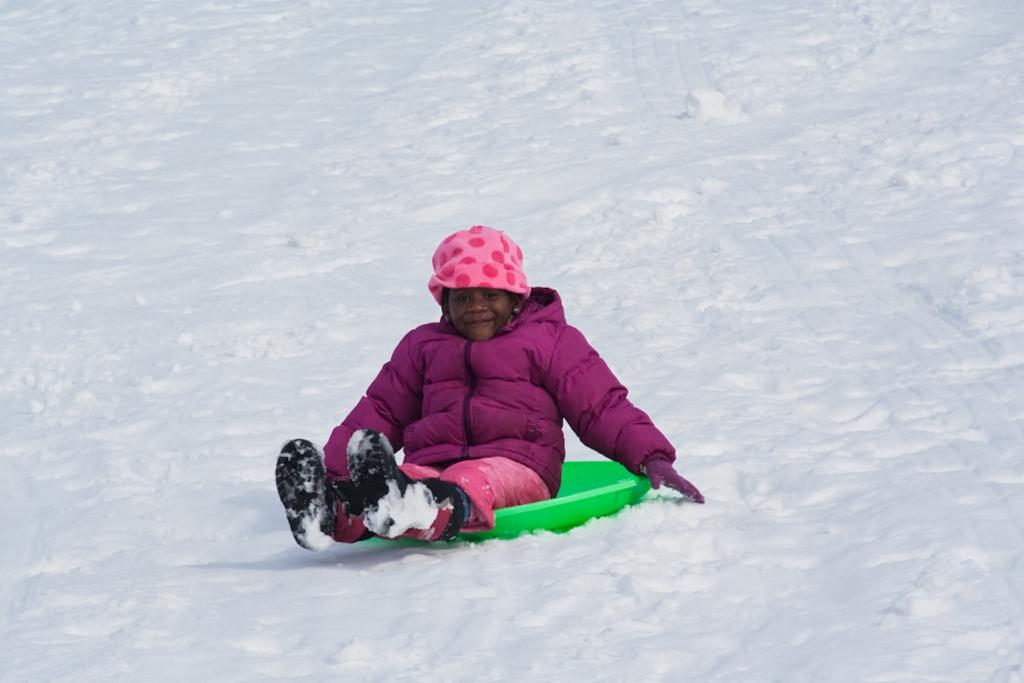What is the weather like in the image? There is snow in the image, indicating a cold and likely wintery environment. What is the person in the image doing? The person is sitting on an object in the image. What might the person be wearing to protect against the cold? The person is wearing a jacket, which is a common clothing item for staying warm in cold weather. What type of brush is being used to connect the person's leg to the object in the image? There is no brush or connection between the person's leg and the object in the image; the person is simply sitting on the object. 